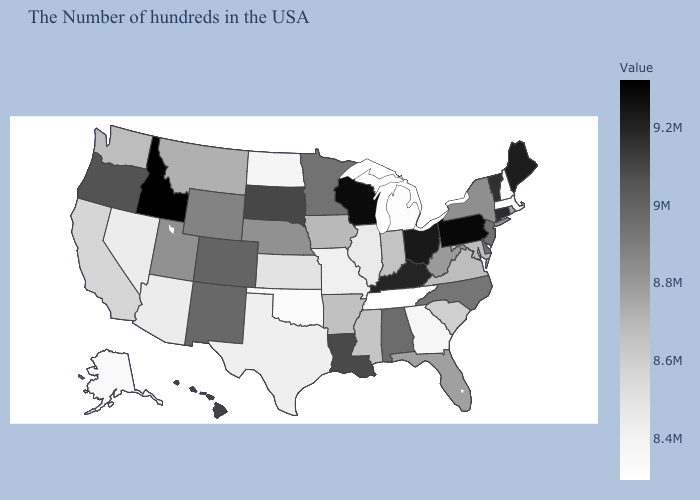Does Illinois have the lowest value in the USA?
Quick response, please. No. Does the map have missing data?
Quick response, please. No. Does Montana have a lower value than New Jersey?
Give a very brief answer. Yes. Which states have the lowest value in the USA?
Short answer required. Tennessee. 